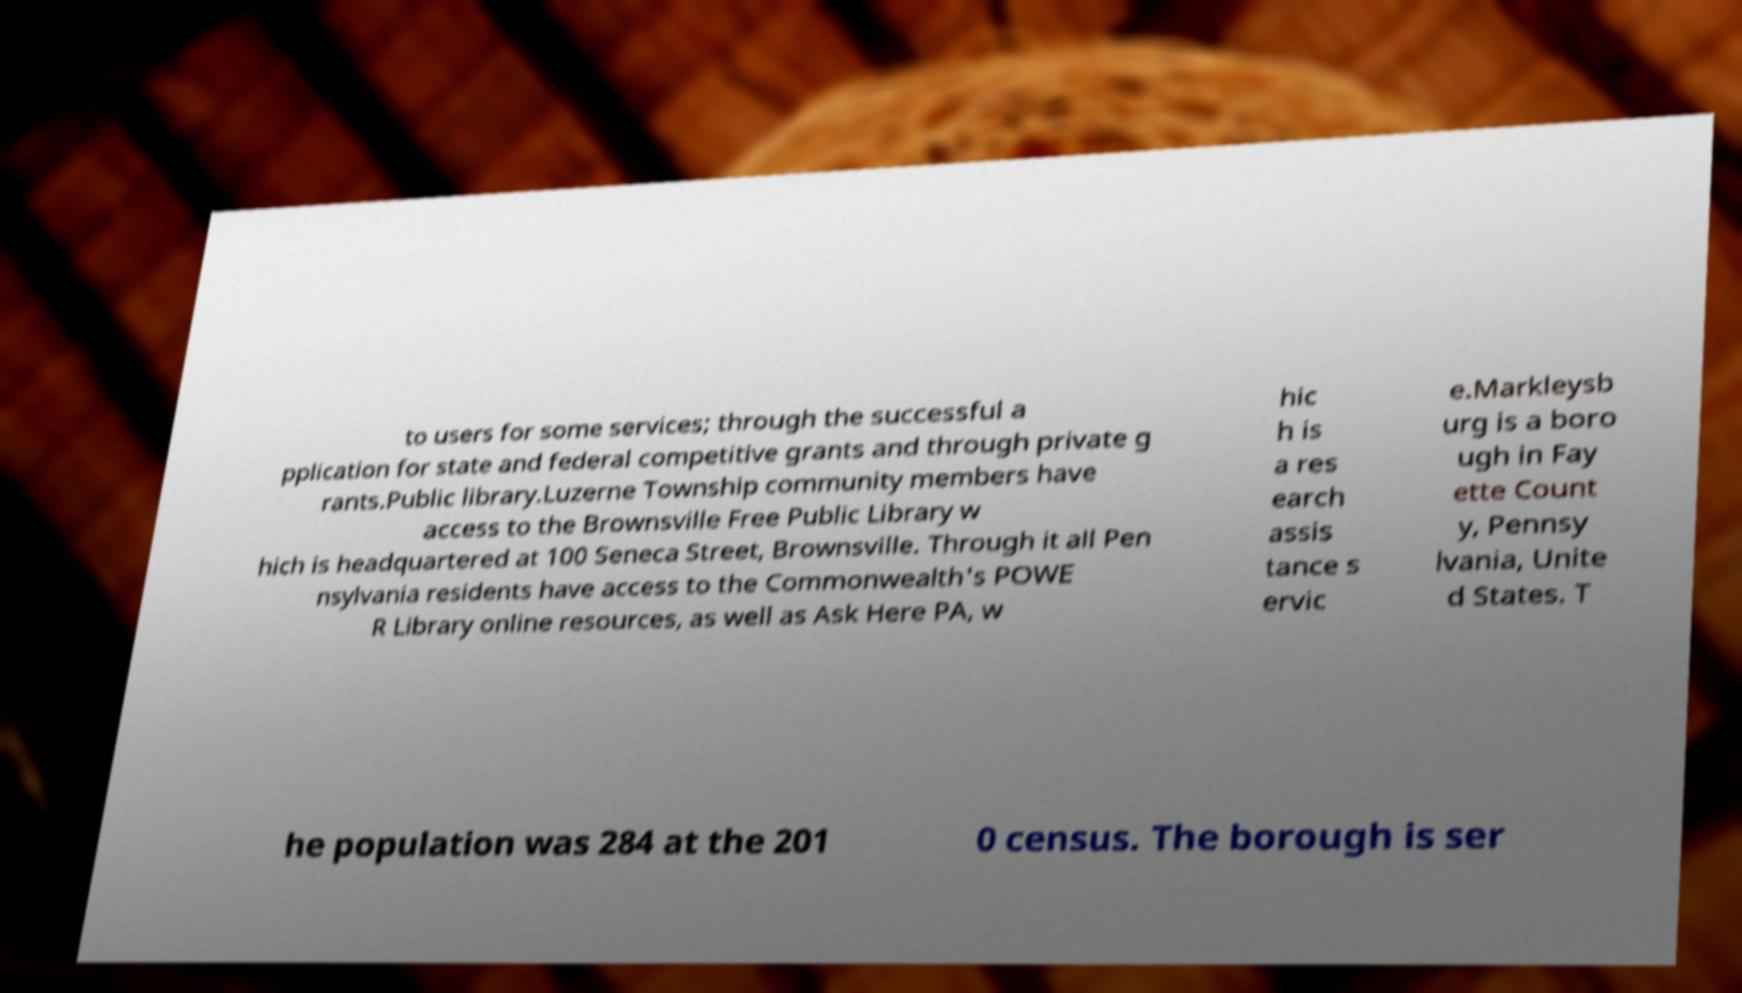For documentation purposes, I need the text within this image transcribed. Could you provide that? to users for some services; through the successful a pplication for state and federal competitive grants and through private g rants.Public library.Luzerne Township community members have access to the Brownsville Free Public Library w hich is headquartered at 100 Seneca Street, Brownsville. Through it all Pen nsylvania residents have access to the Commonwealth's POWE R Library online resources, as well as Ask Here PA, w hic h is a res earch assis tance s ervic e.Markleysb urg is a boro ugh in Fay ette Count y, Pennsy lvania, Unite d States. T he population was 284 at the 201 0 census. The borough is ser 